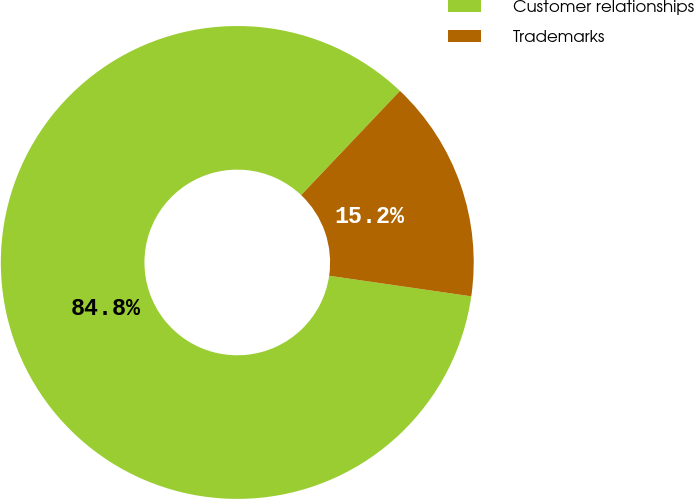<chart> <loc_0><loc_0><loc_500><loc_500><pie_chart><fcel>Customer relationships<fcel>Trademarks<nl><fcel>84.79%<fcel>15.21%<nl></chart> 